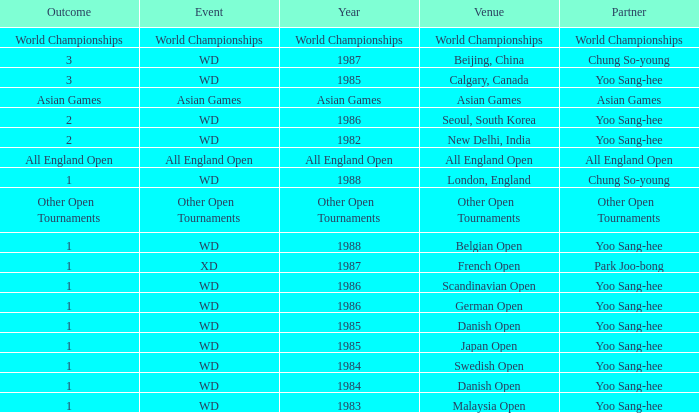What is the Partner during the Asian Games Year? Asian Games. 